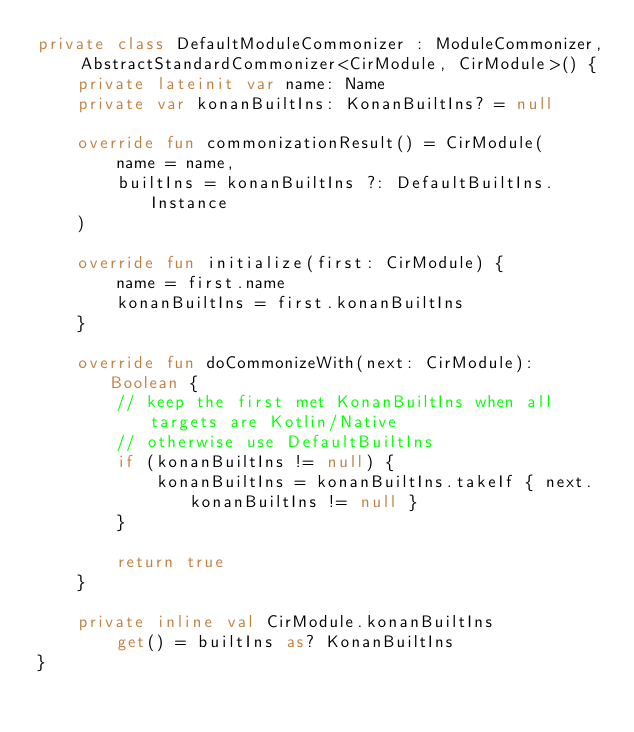<code> <loc_0><loc_0><loc_500><loc_500><_Kotlin_>private class DefaultModuleCommonizer : ModuleCommonizer, AbstractStandardCommonizer<CirModule, CirModule>() {
    private lateinit var name: Name
    private var konanBuiltIns: KonanBuiltIns? = null

    override fun commonizationResult() = CirModule(
        name = name,
        builtIns = konanBuiltIns ?: DefaultBuiltIns.Instance
    )

    override fun initialize(first: CirModule) {
        name = first.name
        konanBuiltIns = first.konanBuiltIns
    }

    override fun doCommonizeWith(next: CirModule): Boolean {
        // keep the first met KonanBuiltIns when all targets are Kotlin/Native
        // otherwise use DefaultBuiltIns
        if (konanBuiltIns != null) {
            konanBuiltIns = konanBuiltIns.takeIf { next.konanBuiltIns != null }
        }

        return true
    }

    private inline val CirModule.konanBuiltIns
        get() = builtIns as? KonanBuiltIns
}
</code> 